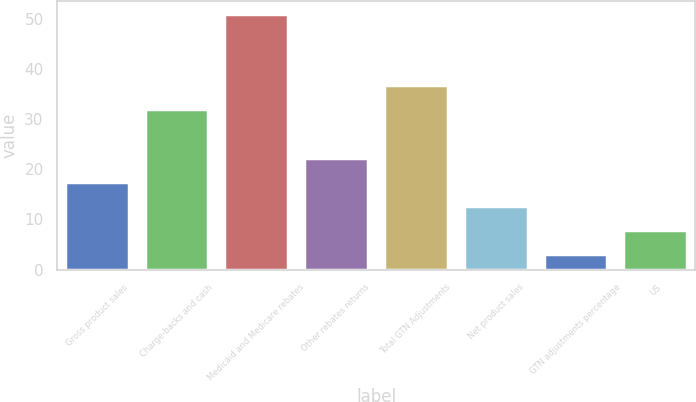<chart> <loc_0><loc_0><loc_500><loc_500><bar_chart><fcel>Gross product sales<fcel>Charge-backs and cash<fcel>Medicaid and Medicare rebates<fcel>Other rebates returns<fcel>Total GTN Adjustments<fcel>Net product sales<fcel>GTN adjustments percentage<fcel>US<nl><fcel>17.4<fcel>32<fcel>51<fcel>22.2<fcel>36.8<fcel>12.6<fcel>3<fcel>7.8<nl></chart> 